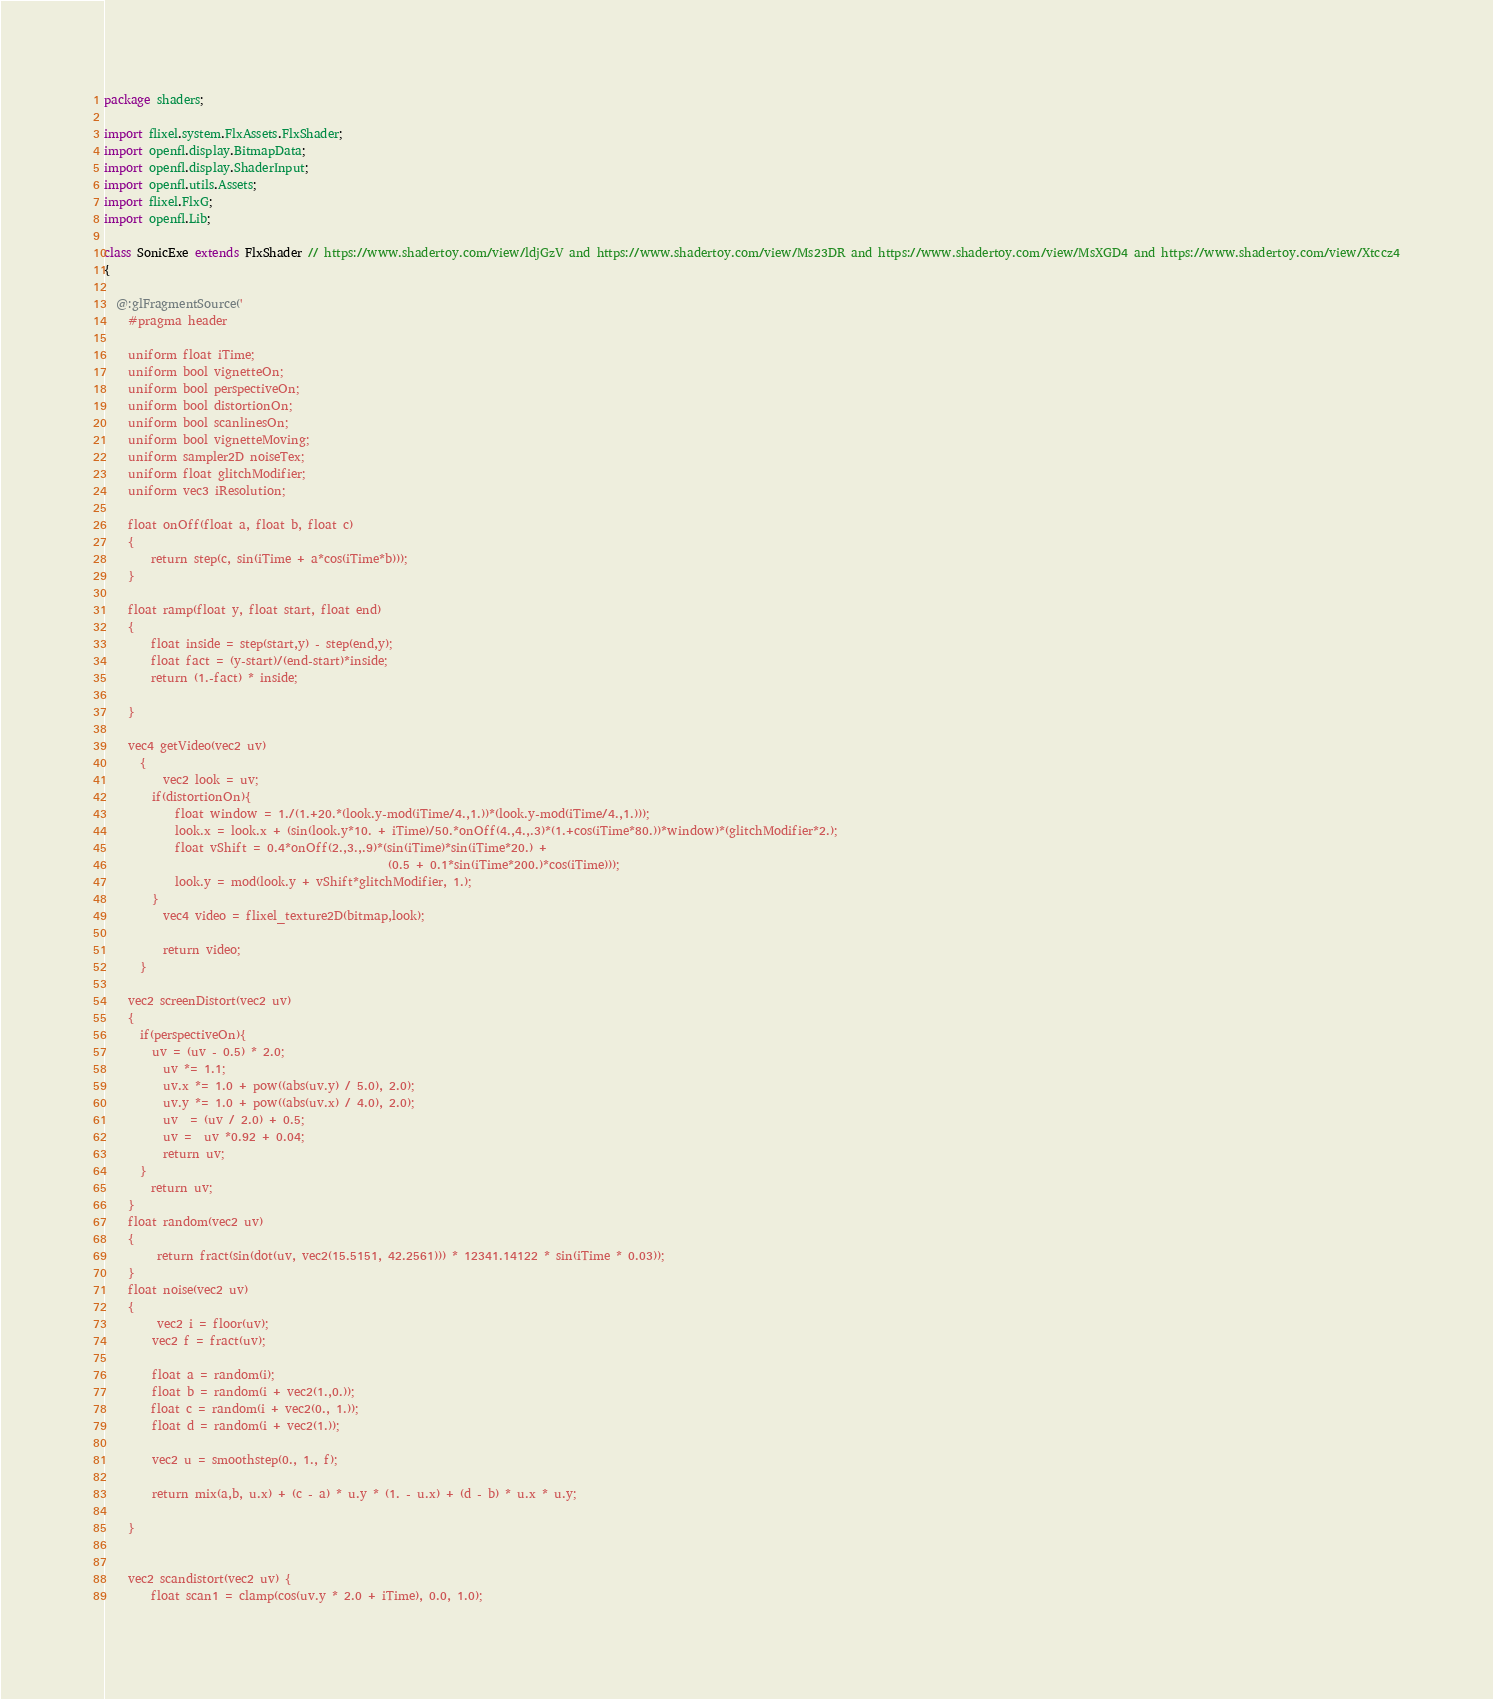Convert code to text. <code><loc_0><loc_0><loc_500><loc_500><_Haxe_>package shaders;

import flixel.system.FlxAssets.FlxShader;
import openfl.display.BitmapData;
import openfl.display.ShaderInput;
import openfl.utils.Assets;
import flixel.FlxG;
import openfl.Lib;

class SonicExe extends FlxShader // https://www.shadertoy.com/view/ldjGzV and https://www.shadertoy.com/view/Ms23DR and https://www.shadertoy.com/view/MsXGD4 and https://www.shadertoy.com/view/Xtccz4
{

  @:glFragmentSource('
    #pragma header

    uniform float iTime;
    uniform bool vignetteOn;
    uniform bool perspectiveOn;
    uniform bool distortionOn;
    uniform bool scanlinesOn;
    uniform bool vignetteMoving;
    uniform sampler2D noiseTex;
    uniform float glitchModifier;
    uniform vec3 iResolution;

    float onOff(float a, float b, float c)
    {
    	return step(c, sin(iTime + a*cos(iTime*b)));
    }

    float ramp(float y, float start, float end)
    {
    	float inside = step(start,y) - step(end,y);
    	float fact = (y-start)/(end-start)*inside;
    	return (1.-fact) * inside;

    }

    vec4 getVideo(vec2 uv)
      {
      	vec2 look = uv;
        if(distortionOn){
        	float window = 1./(1.+20.*(look.y-mod(iTime/4.,1.))*(look.y-mod(iTime/4.,1.)));
        	look.x = look.x + (sin(look.y*10. + iTime)/50.*onOff(4.,4.,.3)*(1.+cos(iTime*80.))*window)*(glitchModifier*2.);
        	float vShift = 0.4*onOff(2.,3.,.9)*(sin(iTime)*sin(iTime*20.) +
        										 (0.5 + 0.1*sin(iTime*200.)*cos(iTime)));
        	look.y = mod(look.y + vShift*glitchModifier, 1.);
        }
      	vec4 video = flixel_texture2D(bitmap,look);

      	return video;
      }

    vec2 screenDistort(vec2 uv)
    {
      if(perspectiveOn){
        uv = (uv - 0.5) * 2.0;
      	uv *= 1.1;
      	uv.x *= 1.0 + pow((abs(uv.y) / 5.0), 2.0);
      	uv.y *= 1.0 + pow((abs(uv.x) / 4.0), 2.0);
      	uv  = (uv / 2.0) + 0.5;
      	uv =  uv *0.92 + 0.04;
      	return uv;
      }
    	return uv;
    }
    float random(vec2 uv)
    {
     	return fract(sin(dot(uv, vec2(15.5151, 42.2561))) * 12341.14122 * sin(iTime * 0.03));
    }
    float noise(vec2 uv)
    {
     	vec2 i = floor(uv);
        vec2 f = fract(uv);

        float a = random(i);
        float b = random(i + vec2(1.,0.));
    	float c = random(i + vec2(0., 1.));
        float d = random(i + vec2(1.));

        vec2 u = smoothstep(0., 1., f);

        return mix(a,b, u.x) + (c - a) * u.y * (1. - u.x) + (d - b) * u.x * u.y;

    }


    vec2 scandistort(vec2 uv) {
    	float scan1 = clamp(cos(uv.y * 2.0 + iTime), 0.0, 1.0);</code> 